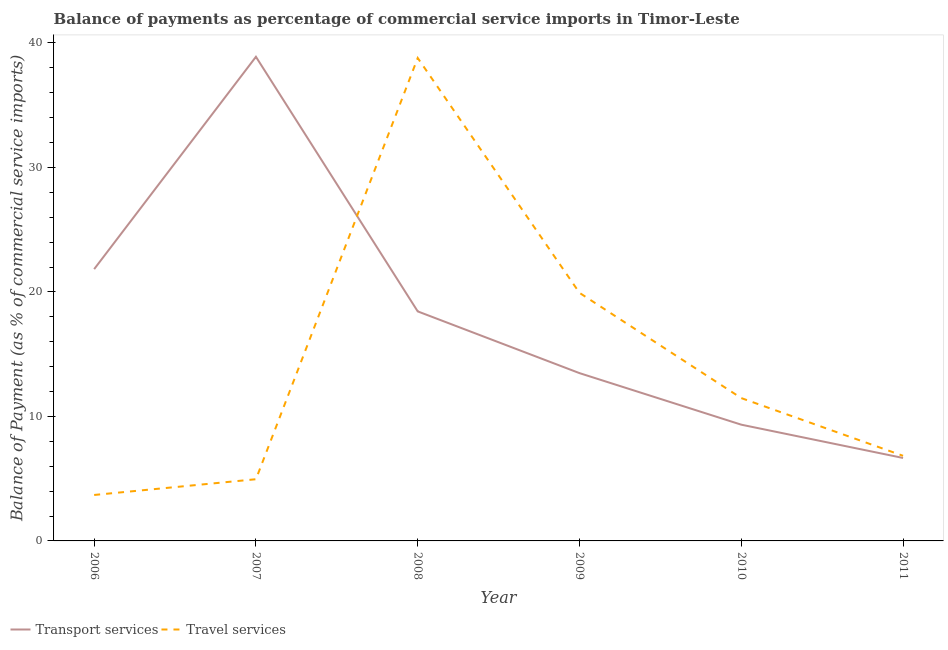How many different coloured lines are there?
Keep it short and to the point. 2. Is the number of lines equal to the number of legend labels?
Offer a terse response. Yes. What is the balance of payments of transport services in 2007?
Make the answer very short. 38.89. Across all years, what is the maximum balance of payments of transport services?
Your answer should be compact. 38.89. Across all years, what is the minimum balance of payments of travel services?
Keep it short and to the point. 3.69. In which year was the balance of payments of transport services minimum?
Offer a very short reply. 2011. What is the total balance of payments of transport services in the graph?
Make the answer very short. 108.64. What is the difference between the balance of payments of travel services in 2009 and that in 2010?
Make the answer very short. 8.45. What is the difference between the balance of payments of travel services in 2006 and the balance of payments of transport services in 2011?
Your answer should be very brief. -2.97. What is the average balance of payments of transport services per year?
Make the answer very short. 18.11. In the year 2010, what is the difference between the balance of payments of transport services and balance of payments of travel services?
Give a very brief answer. -2.14. In how many years, is the balance of payments of transport services greater than 12 %?
Ensure brevity in your answer.  4. What is the ratio of the balance of payments of travel services in 2008 to that in 2010?
Make the answer very short. 3.38. Is the balance of payments of travel services in 2007 less than that in 2009?
Offer a terse response. Yes. What is the difference between the highest and the second highest balance of payments of travel services?
Keep it short and to the point. 18.87. What is the difference between the highest and the lowest balance of payments of transport services?
Give a very brief answer. 32.22. In how many years, is the balance of payments of transport services greater than the average balance of payments of transport services taken over all years?
Provide a succinct answer. 3. Is the sum of the balance of payments of travel services in 2006 and 2007 greater than the maximum balance of payments of transport services across all years?
Provide a succinct answer. No. Does the balance of payments of travel services monotonically increase over the years?
Ensure brevity in your answer.  No. Is the balance of payments of travel services strictly less than the balance of payments of transport services over the years?
Ensure brevity in your answer.  No. How many lines are there?
Keep it short and to the point. 2. What is the difference between two consecutive major ticks on the Y-axis?
Provide a short and direct response. 10. Are the values on the major ticks of Y-axis written in scientific E-notation?
Your answer should be compact. No. How many legend labels are there?
Make the answer very short. 2. What is the title of the graph?
Your answer should be very brief. Balance of payments as percentage of commercial service imports in Timor-Leste. Does "Transport services" appear as one of the legend labels in the graph?
Make the answer very short. Yes. What is the label or title of the X-axis?
Your answer should be very brief. Year. What is the label or title of the Y-axis?
Ensure brevity in your answer.  Balance of Payment (as % of commercial service imports). What is the Balance of Payment (as % of commercial service imports) of Transport services in 2006?
Keep it short and to the point. 21.83. What is the Balance of Payment (as % of commercial service imports) in Travel services in 2006?
Offer a terse response. 3.69. What is the Balance of Payment (as % of commercial service imports) of Transport services in 2007?
Provide a succinct answer. 38.89. What is the Balance of Payment (as % of commercial service imports) in Travel services in 2007?
Offer a very short reply. 4.96. What is the Balance of Payment (as % of commercial service imports) in Transport services in 2008?
Make the answer very short. 18.44. What is the Balance of Payment (as % of commercial service imports) of Travel services in 2008?
Make the answer very short. 38.79. What is the Balance of Payment (as % of commercial service imports) in Transport services in 2009?
Provide a short and direct response. 13.48. What is the Balance of Payment (as % of commercial service imports) of Travel services in 2009?
Give a very brief answer. 19.93. What is the Balance of Payment (as % of commercial service imports) in Transport services in 2010?
Give a very brief answer. 9.34. What is the Balance of Payment (as % of commercial service imports) of Travel services in 2010?
Make the answer very short. 11.47. What is the Balance of Payment (as % of commercial service imports) in Transport services in 2011?
Your answer should be very brief. 6.66. What is the Balance of Payment (as % of commercial service imports) in Travel services in 2011?
Offer a terse response. 6.84. Across all years, what is the maximum Balance of Payment (as % of commercial service imports) in Transport services?
Give a very brief answer. 38.89. Across all years, what is the maximum Balance of Payment (as % of commercial service imports) of Travel services?
Ensure brevity in your answer.  38.79. Across all years, what is the minimum Balance of Payment (as % of commercial service imports) of Transport services?
Your answer should be compact. 6.66. Across all years, what is the minimum Balance of Payment (as % of commercial service imports) in Travel services?
Offer a terse response. 3.69. What is the total Balance of Payment (as % of commercial service imports) of Transport services in the graph?
Keep it short and to the point. 108.64. What is the total Balance of Payment (as % of commercial service imports) in Travel services in the graph?
Provide a succinct answer. 85.68. What is the difference between the Balance of Payment (as % of commercial service imports) of Transport services in 2006 and that in 2007?
Give a very brief answer. -17.06. What is the difference between the Balance of Payment (as % of commercial service imports) in Travel services in 2006 and that in 2007?
Ensure brevity in your answer.  -1.26. What is the difference between the Balance of Payment (as % of commercial service imports) in Transport services in 2006 and that in 2008?
Ensure brevity in your answer.  3.39. What is the difference between the Balance of Payment (as % of commercial service imports) in Travel services in 2006 and that in 2008?
Ensure brevity in your answer.  -35.1. What is the difference between the Balance of Payment (as % of commercial service imports) of Transport services in 2006 and that in 2009?
Make the answer very short. 8.35. What is the difference between the Balance of Payment (as % of commercial service imports) in Travel services in 2006 and that in 2009?
Your response must be concise. -16.24. What is the difference between the Balance of Payment (as % of commercial service imports) of Transport services in 2006 and that in 2010?
Offer a very short reply. 12.49. What is the difference between the Balance of Payment (as % of commercial service imports) in Travel services in 2006 and that in 2010?
Your answer should be very brief. -7.78. What is the difference between the Balance of Payment (as % of commercial service imports) of Transport services in 2006 and that in 2011?
Offer a very short reply. 15.17. What is the difference between the Balance of Payment (as % of commercial service imports) of Travel services in 2006 and that in 2011?
Your answer should be compact. -3.15. What is the difference between the Balance of Payment (as % of commercial service imports) in Transport services in 2007 and that in 2008?
Your answer should be very brief. 20.45. What is the difference between the Balance of Payment (as % of commercial service imports) in Travel services in 2007 and that in 2008?
Offer a very short reply. -33.84. What is the difference between the Balance of Payment (as % of commercial service imports) of Transport services in 2007 and that in 2009?
Ensure brevity in your answer.  25.41. What is the difference between the Balance of Payment (as % of commercial service imports) of Travel services in 2007 and that in 2009?
Your answer should be compact. -14.97. What is the difference between the Balance of Payment (as % of commercial service imports) of Transport services in 2007 and that in 2010?
Offer a very short reply. 29.55. What is the difference between the Balance of Payment (as % of commercial service imports) of Travel services in 2007 and that in 2010?
Your answer should be compact. -6.52. What is the difference between the Balance of Payment (as % of commercial service imports) in Transport services in 2007 and that in 2011?
Offer a terse response. 32.22. What is the difference between the Balance of Payment (as % of commercial service imports) of Travel services in 2007 and that in 2011?
Provide a succinct answer. -1.88. What is the difference between the Balance of Payment (as % of commercial service imports) in Transport services in 2008 and that in 2009?
Keep it short and to the point. 4.96. What is the difference between the Balance of Payment (as % of commercial service imports) in Travel services in 2008 and that in 2009?
Your answer should be compact. 18.87. What is the difference between the Balance of Payment (as % of commercial service imports) in Transport services in 2008 and that in 2010?
Your answer should be very brief. 9.1. What is the difference between the Balance of Payment (as % of commercial service imports) in Travel services in 2008 and that in 2010?
Offer a very short reply. 27.32. What is the difference between the Balance of Payment (as % of commercial service imports) in Transport services in 2008 and that in 2011?
Offer a very short reply. 11.77. What is the difference between the Balance of Payment (as % of commercial service imports) in Travel services in 2008 and that in 2011?
Provide a short and direct response. 31.95. What is the difference between the Balance of Payment (as % of commercial service imports) in Transport services in 2009 and that in 2010?
Provide a short and direct response. 4.14. What is the difference between the Balance of Payment (as % of commercial service imports) of Travel services in 2009 and that in 2010?
Offer a very short reply. 8.45. What is the difference between the Balance of Payment (as % of commercial service imports) of Transport services in 2009 and that in 2011?
Make the answer very short. 6.81. What is the difference between the Balance of Payment (as % of commercial service imports) in Travel services in 2009 and that in 2011?
Make the answer very short. 13.09. What is the difference between the Balance of Payment (as % of commercial service imports) in Transport services in 2010 and that in 2011?
Provide a short and direct response. 2.67. What is the difference between the Balance of Payment (as % of commercial service imports) in Travel services in 2010 and that in 2011?
Give a very brief answer. 4.64. What is the difference between the Balance of Payment (as % of commercial service imports) of Transport services in 2006 and the Balance of Payment (as % of commercial service imports) of Travel services in 2007?
Keep it short and to the point. 16.88. What is the difference between the Balance of Payment (as % of commercial service imports) of Transport services in 2006 and the Balance of Payment (as % of commercial service imports) of Travel services in 2008?
Ensure brevity in your answer.  -16.96. What is the difference between the Balance of Payment (as % of commercial service imports) of Transport services in 2006 and the Balance of Payment (as % of commercial service imports) of Travel services in 2009?
Your answer should be very brief. 1.9. What is the difference between the Balance of Payment (as % of commercial service imports) of Transport services in 2006 and the Balance of Payment (as % of commercial service imports) of Travel services in 2010?
Make the answer very short. 10.36. What is the difference between the Balance of Payment (as % of commercial service imports) of Transport services in 2006 and the Balance of Payment (as % of commercial service imports) of Travel services in 2011?
Offer a very short reply. 14.99. What is the difference between the Balance of Payment (as % of commercial service imports) in Transport services in 2007 and the Balance of Payment (as % of commercial service imports) in Travel services in 2008?
Keep it short and to the point. 0.1. What is the difference between the Balance of Payment (as % of commercial service imports) of Transport services in 2007 and the Balance of Payment (as % of commercial service imports) of Travel services in 2009?
Keep it short and to the point. 18.96. What is the difference between the Balance of Payment (as % of commercial service imports) of Transport services in 2007 and the Balance of Payment (as % of commercial service imports) of Travel services in 2010?
Offer a very short reply. 27.42. What is the difference between the Balance of Payment (as % of commercial service imports) in Transport services in 2007 and the Balance of Payment (as % of commercial service imports) in Travel services in 2011?
Keep it short and to the point. 32.05. What is the difference between the Balance of Payment (as % of commercial service imports) of Transport services in 2008 and the Balance of Payment (as % of commercial service imports) of Travel services in 2009?
Make the answer very short. -1.49. What is the difference between the Balance of Payment (as % of commercial service imports) in Transport services in 2008 and the Balance of Payment (as % of commercial service imports) in Travel services in 2010?
Your answer should be very brief. 6.96. What is the difference between the Balance of Payment (as % of commercial service imports) of Transport services in 2008 and the Balance of Payment (as % of commercial service imports) of Travel services in 2011?
Your answer should be very brief. 11.6. What is the difference between the Balance of Payment (as % of commercial service imports) in Transport services in 2009 and the Balance of Payment (as % of commercial service imports) in Travel services in 2010?
Your answer should be compact. 2.01. What is the difference between the Balance of Payment (as % of commercial service imports) in Transport services in 2009 and the Balance of Payment (as % of commercial service imports) in Travel services in 2011?
Make the answer very short. 6.64. What is the difference between the Balance of Payment (as % of commercial service imports) in Transport services in 2010 and the Balance of Payment (as % of commercial service imports) in Travel services in 2011?
Offer a very short reply. 2.5. What is the average Balance of Payment (as % of commercial service imports) in Transport services per year?
Make the answer very short. 18.11. What is the average Balance of Payment (as % of commercial service imports) in Travel services per year?
Your response must be concise. 14.28. In the year 2006, what is the difference between the Balance of Payment (as % of commercial service imports) in Transport services and Balance of Payment (as % of commercial service imports) in Travel services?
Offer a terse response. 18.14. In the year 2007, what is the difference between the Balance of Payment (as % of commercial service imports) in Transport services and Balance of Payment (as % of commercial service imports) in Travel services?
Make the answer very short. 33.93. In the year 2008, what is the difference between the Balance of Payment (as % of commercial service imports) of Transport services and Balance of Payment (as % of commercial service imports) of Travel services?
Provide a succinct answer. -20.35. In the year 2009, what is the difference between the Balance of Payment (as % of commercial service imports) in Transport services and Balance of Payment (as % of commercial service imports) in Travel services?
Offer a very short reply. -6.45. In the year 2010, what is the difference between the Balance of Payment (as % of commercial service imports) of Transport services and Balance of Payment (as % of commercial service imports) of Travel services?
Offer a very short reply. -2.14. In the year 2011, what is the difference between the Balance of Payment (as % of commercial service imports) in Transport services and Balance of Payment (as % of commercial service imports) in Travel services?
Ensure brevity in your answer.  -0.17. What is the ratio of the Balance of Payment (as % of commercial service imports) in Transport services in 2006 to that in 2007?
Provide a succinct answer. 0.56. What is the ratio of the Balance of Payment (as % of commercial service imports) in Travel services in 2006 to that in 2007?
Provide a short and direct response. 0.74. What is the ratio of the Balance of Payment (as % of commercial service imports) of Transport services in 2006 to that in 2008?
Provide a short and direct response. 1.18. What is the ratio of the Balance of Payment (as % of commercial service imports) in Travel services in 2006 to that in 2008?
Provide a short and direct response. 0.1. What is the ratio of the Balance of Payment (as % of commercial service imports) of Transport services in 2006 to that in 2009?
Provide a short and direct response. 1.62. What is the ratio of the Balance of Payment (as % of commercial service imports) in Travel services in 2006 to that in 2009?
Make the answer very short. 0.19. What is the ratio of the Balance of Payment (as % of commercial service imports) of Transport services in 2006 to that in 2010?
Keep it short and to the point. 2.34. What is the ratio of the Balance of Payment (as % of commercial service imports) of Travel services in 2006 to that in 2010?
Ensure brevity in your answer.  0.32. What is the ratio of the Balance of Payment (as % of commercial service imports) of Transport services in 2006 to that in 2011?
Provide a short and direct response. 3.28. What is the ratio of the Balance of Payment (as % of commercial service imports) in Travel services in 2006 to that in 2011?
Keep it short and to the point. 0.54. What is the ratio of the Balance of Payment (as % of commercial service imports) in Transport services in 2007 to that in 2008?
Give a very brief answer. 2.11. What is the ratio of the Balance of Payment (as % of commercial service imports) in Travel services in 2007 to that in 2008?
Provide a succinct answer. 0.13. What is the ratio of the Balance of Payment (as % of commercial service imports) of Transport services in 2007 to that in 2009?
Offer a terse response. 2.89. What is the ratio of the Balance of Payment (as % of commercial service imports) of Travel services in 2007 to that in 2009?
Your answer should be compact. 0.25. What is the ratio of the Balance of Payment (as % of commercial service imports) in Transport services in 2007 to that in 2010?
Your answer should be compact. 4.16. What is the ratio of the Balance of Payment (as % of commercial service imports) in Travel services in 2007 to that in 2010?
Keep it short and to the point. 0.43. What is the ratio of the Balance of Payment (as % of commercial service imports) of Transport services in 2007 to that in 2011?
Offer a terse response. 5.84. What is the ratio of the Balance of Payment (as % of commercial service imports) of Travel services in 2007 to that in 2011?
Your response must be concise. 0.72. What is the ratio of the Balance of Payment (as % of commercial service imports) in Transport services in 2008 to that in 2009?
Ensure brevity in your answer.  1.37. What is the ratio of the Balance of Payment (as % of commercial service imports) in Travel services in 2008 to that in 2009?
Your answer should be very brief. 1.95. What is the ratio of the Balance of Payment (as % of commercial service imports) of Transport services in 2008 to that in 2010?
Your answer should be very brief. 1.97. What is the ratio of the Balance of Payment (as % of commercial service imports) in Travel services in 2008 to that in 2010?
Provide a succinct answer. 3.38. What is the ratio of the Balance of Payment (as % of commercial service imports) in Transport services in 2008 to that in 2011?
Make the answer very short. 2.77. What is the ratio of the Balance of Payment (as % of commercial service imports) of Travel services in 2008 to that in 2011?
Provide a short and direct response. 5.67. What is the ratio of the Balance of Payment (as % of commercial service imports) of Transport services in 2009 to that in 2010?
Ensure brevity in your answer.  1.44. What is the ratio of the Balance of Payment (as % of commercial service imports) in Travel services in 2009 to that in 2010?
Offer a terse response. 1.74. What is the ratio of the Balance of Payment (as % of commercial service imports) of Transport services in 2009 to that in 2011?
Offer a very short reply. 2.02. What is the ratio of the Balance of Payment (as % of commercial service imports) in Travel services in 2009 to that in 2011?
Offer a terse response. 2.91. What is the ratio of the Balance of Payment (as % of commercial service imports) of Transport services in 2010 to that in 2011?
Ensure brevity in your answer.  1.4. What is the ratio of the Balance of Payment (as % of commercial service imports) of Travel services in 2010 to that in 2011?
Keep it short and to the point. 1.68. What is the difference between the highest and the second highest Balance of Payment (as % of commercial service imports) of Transport services?
Provide a succinct answer. 17.06. What is the difference between the highest and the second highest Balance of Payment (as % of commercial service imports) in Travel services?
Your response must be concise. 18.87. What is the difference between the highest and the lowest Balance of Payment (as % of commercial service imports) in Transport services?
Make the answer very short. 32.22. What is the difference between the highest and the lowest Balance of Payment (as % of commercial service imports) of Travel services?
Offer a terse response. 35.1. 